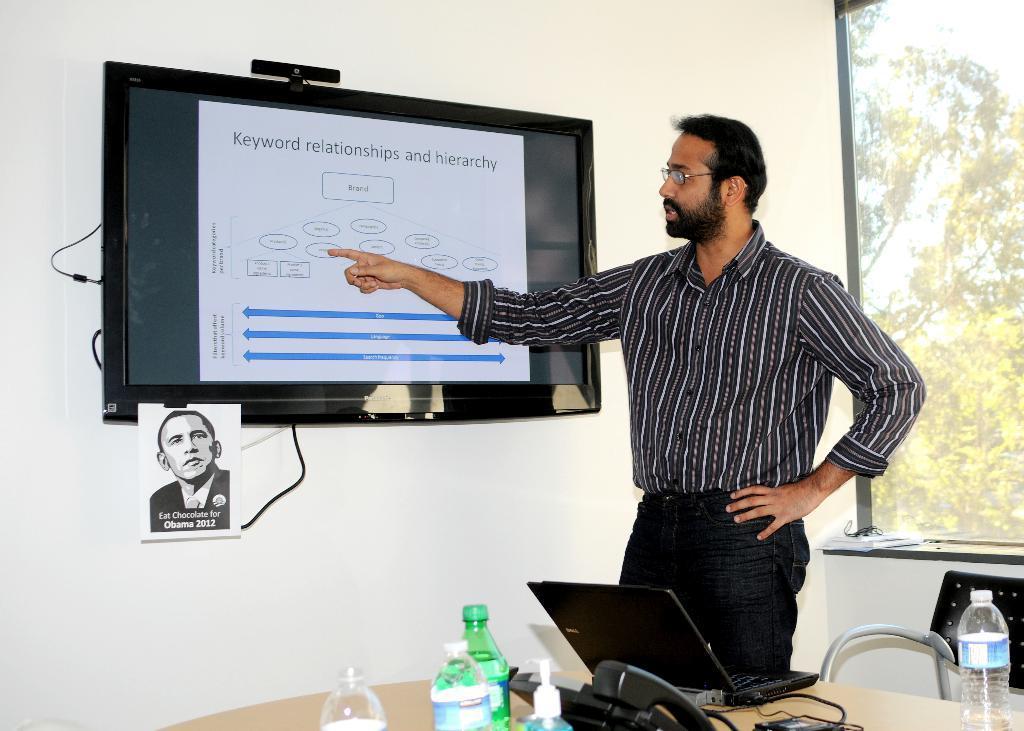Could you give a brief overview of what you see in this image? This picture is inside the room. There is a person standing and talking and he is pointing towards the screen. There is a screen on the wall. There are laptop, telephone, bottles on the table, and there is a chair behind the table. At the back there is a window. 